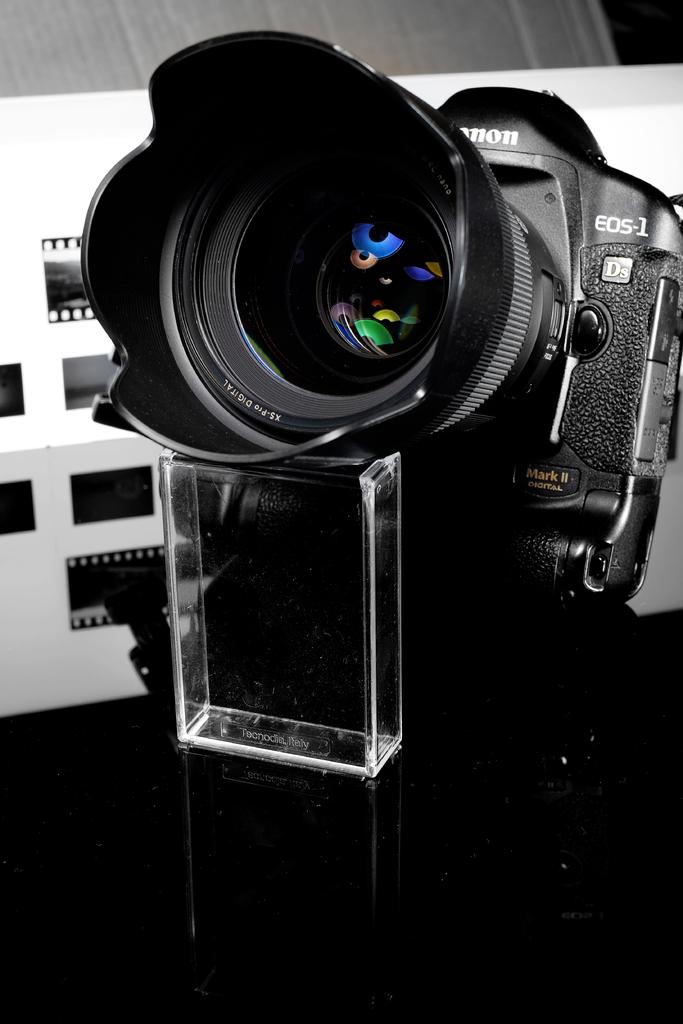What is the main subject in the center of the image? There is a camera in the center of the image. What can be seen in the background of the image? There is a wall in the background of the image. What is hanging on the wall in the background? There are reels on the wall in the background. How many babies are present in the image? A: There are no babies present in the image. What type of wood is used to make the camera in the image? The image does not provide information about the material used to make the camera, and there is no wood visible in the image. 